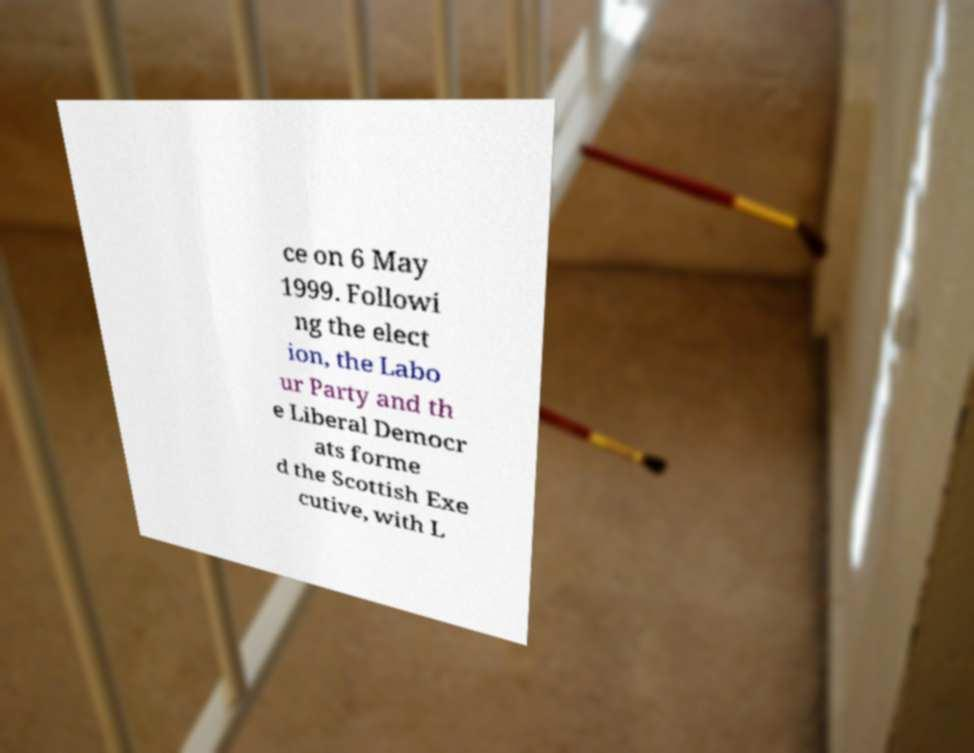Can you accurately transcribe the text from the provided image for me? ce on 6 May 1999. Followi ng the elect ion, the Labo ur Party and th e Liberal Democr ats forme d the Scottish Exe cutive, with L 